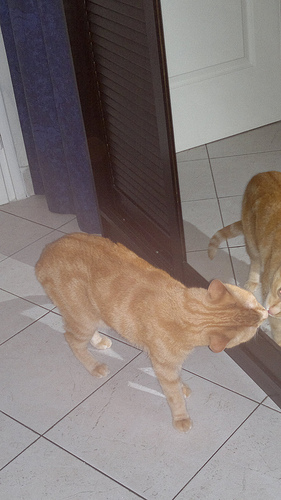<image>
Is there a cat on the ground? Yes. Looking at the image, I can see the cat is positioned on top of the ground, with the ground providing support. Is the cat to the left of the mirror? Yes. From this viewpoint, the cat is positioned to the left side relative to the mirror. Where is the cat in relation to the mirror? Is it under the mirror? No. The cat is not positioned under the mirror. The vertical relationship between these objects is different. Is the door behind the cat? Yes. From this viewpoint, the door is positioned behind the cat, with the cat partially or fully occluding the door. 